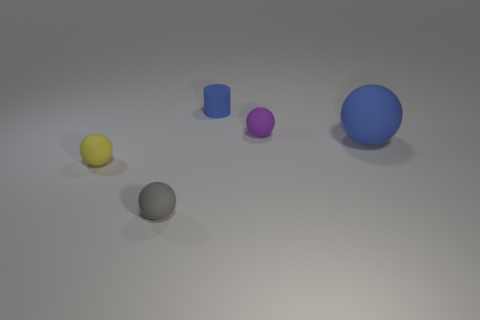Is there any other thing that has the same size as the blue matte ball?
Your answer should be compact. No. Is the size of the cylinder the same as the blue ball?
Your answer should be very brief. No. How many large objects are either rubber cylinders or blue metallic cylinders?
Provide a succinct answer. 0. What number of purple things are behind the small purple rubber ball?
Your answer should be compact. 0. Is the number of rubber things behind the small yellow matte object greater than the number of purple metallic blocks?
Keep it short and to the point. Yes. What shape is the purple object that is made of the same material as the tiny cylinder?
Make the answer very short. Sphere. What is the color of the small ball that is behind the object on the right side of the small purple thing?
Your answer should be compact. Purple. Does the purple object have the same shape as the large blue thing?
Keep it short and to the point. Yes. There is a small yellow thing that is the same shape as the gray object; what is it made of?
Your answer should be compact. Rubber. Are there any large balls that are behind the rubber object that is in front of the sphere that is to the left of the tiny gray thing?
Provide a short and direct response. Yes. 